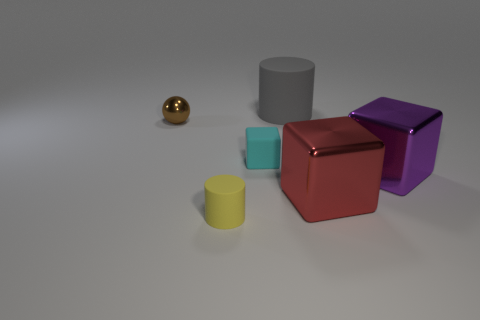What number of red things are rubber objects or large metallic things?
Offer a terse response. 1. There is a red block that is made of the same material as the purple block; what size is it?
Offer a very short reply. Large. What number of cyan objects have the same shape as the purple thing?
Your answer should be compact. 1. Are there more large red shiny blocks that are in front of the yellow cylinder than purple cubes to the right of the big purple block?
Your answer should be compact. No. Does the tiny metal ball have the same color as the rubber object behind the brown sphere?
Keep it short and to the point. No. What material is the cylinder that is the same size as the purple metal thing?
Ensure brevity in your answer.  Rubber. What number of things are either big brown metallic blocks or tiny rubber things left of the small matte block?
Offer a very short reply. 1. Does the red thing have the same size as the block to the left of the gray cylinder?
Your response must be concise. No. What number of cylinders are yellow objects or red shiny objects?
Provide a short and direct response. 1. How many metallic objects are behind the tiny block and to the right of the tiny brown metallic thing?
Ensure brevity in your answer.  0. 